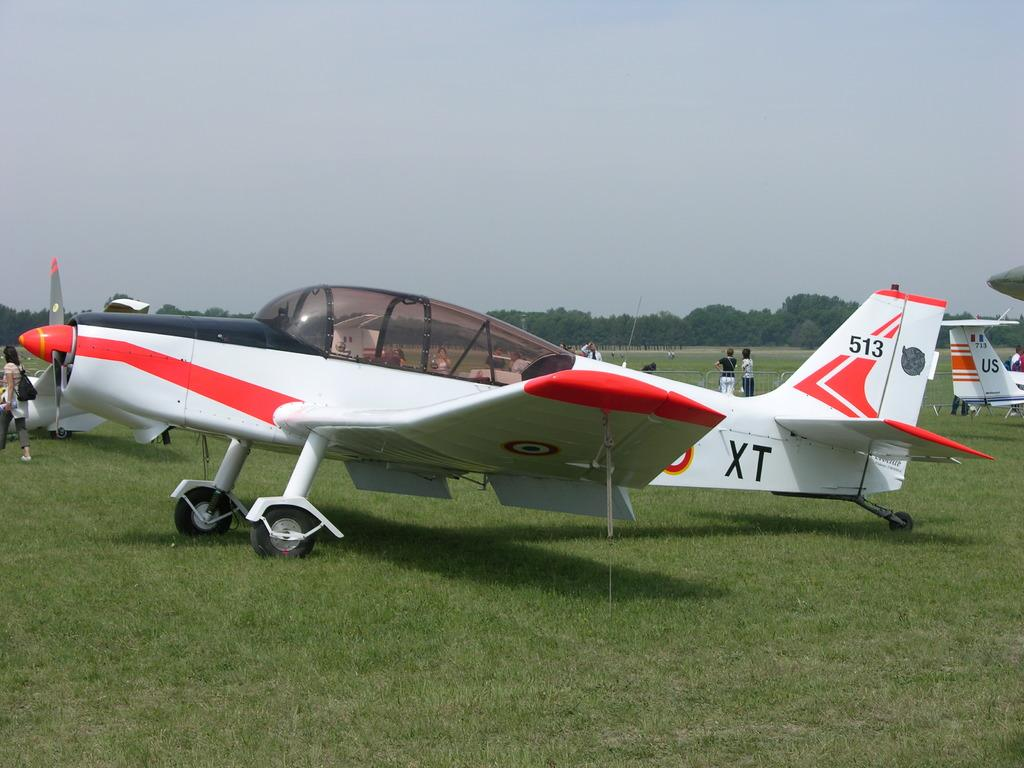<image>
Summarize the visual content of the image. An orange and white propeller plane has XT and 51 